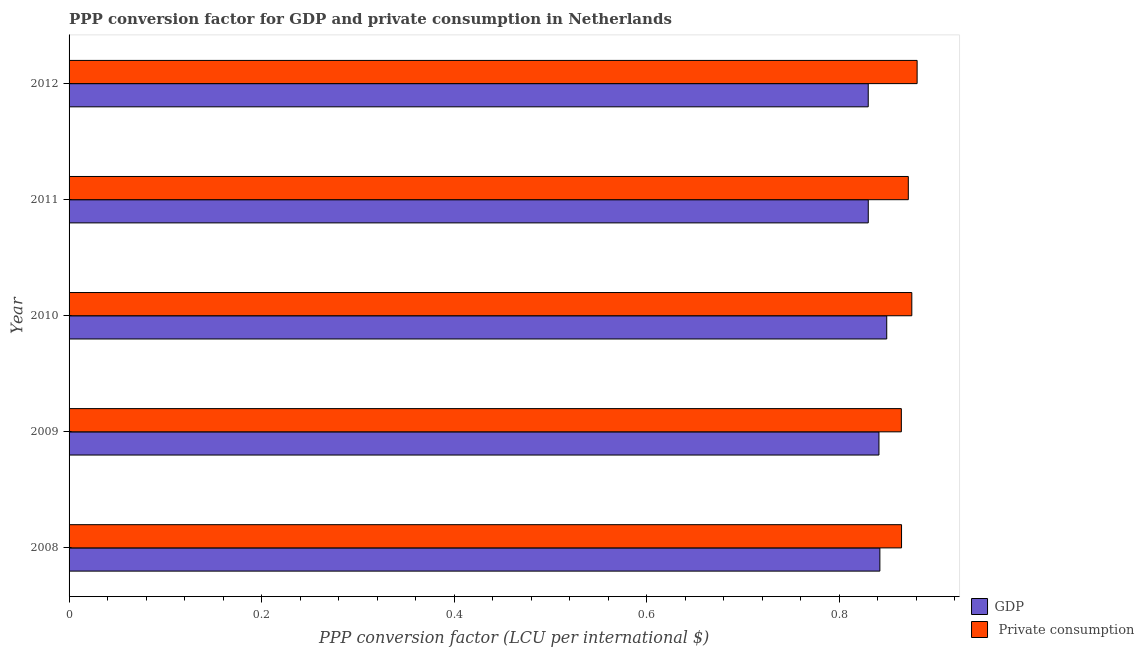Are the number of bars on each tick of the Y-axis equal?
Keep it short and to the point. Yes. How many bars are there on the 4th tick from the top?
Offer a very short reply. 2. How many bars are there on the 5th tick from the bottom?
Ensure brevity in your answer.  2. In how many cases, is the number of bars for a given year not equal to the number of legend labels?
Your answer should be compact. 0. What is the ppp conversion factor for gdp in 2008?
Offer a terse response. 0.84. Across all years, what is the maximum ppp conversion factor for private consumption?
Your response must be concise. 0.88. Across all years, what is the minimum ppp conversion factor for gdp?
Provide a succinct answer. 0.83. In which year was the ppp conversion factor for private consumption minimum?
Offer a very short reply. 2009. What is the total ppp conversion factor for private consumption in the graph?
Give a very brief answer. 4.36. What is the difference between the ppp conversion factor for private consumption in 2008 and that in 2009?
Keep it short and to the point. 0. What is the difference between the ppp conversion factor for gdp in 2012 and the ppp conversion factor for private consumption in 2008?
Make the answer very short. -0.03. What is the average ppp conversion factor for gdp per year?
Your answer should be very brief. 0.84. In the year 2009, what is the difference between the ppp conversion factor for private consumption and ppp conversion factor for gdp?
Offer a very short reply. 0.02. In how many years, is the ppp conversion factor for gdp greater than 0.32 LCU?
Your response must be concise. 5. What is the ratio of the ppp conversion factor for gdp in 2011 to that in 2012?
Provide a succinct answer. 1. What is the difference between the highest and the second highest ppp conversion factor for gdp?
Ensure brevity in your answer.  0.01. Is the sum of the ppp conversion factor for private consumption in 2009 and 2011 greater than the maximum ppp conversion factor for gdp across all years?
Give a very brief answer. Yes. What does the 1st bar from the top in 2009 represents?
Your answer should be compact.  Private consumption. What does the 1st bar from the bottom in 2010 represents?
Provide a short and direct response. GDP. How many bars are there?
Your answer should be compact. 10. Are the values on the major ticks of X-axis written in scientific E-notation?
Offer a terse response. No. Does the graph contain grids?
Offer a terse response. No. Where does the legend appear in the graph?
Your response must be concise. Bottom right. How are the legend labels stacked?
Offer a terse response. Vertical. What is the title of the graph?
Your response must be concise. PPP conversion factor for GDP and private consumption in Netherlands. What is the label or title of the X-axis?
Make the answer very short. PPP conversion factor (LCU per international $). What is the label or title of the Y-axis?
Offer a very short reply. Year. What is the PPP conversion factor (LCU per international $) of GDP in 2008?
Your answer should be compact. 0.84. What is the PPP conversion factor (LCU per international $) in  Private consumption in 2008?
Your response must be concise. 0.86. What is the PPP conversion factor (LCU per international $) of GDP in 2009?
Provide a succinct answer. 0.84. What is the PPP conversion factor (LCU per international $) of  Private consumption in 2009?
Make the answer very short. 0.86. What is the PPP conversion factor (LCU per international $) of GDP in 2010?
Offer a very short reply. 0.85. What is the PPP conversion factor (LCU per international $) of  Private consumption in 2010?
Give a very brief answer. 0.88. What is the PPP conversion factor (LCU per international $) in GDP in 2011?
Your answer should be compact. 0.83. What is the PPP conversion factor (LCU per international $) in  Private consumption in 2011?
Your answer should be compact. 0.87. What is the PPP conversion factor (LCU per international $) in GDP in 2012?
Provide a succinct answer. 0.83. What is the PPP conversion factor (LCU per international $) in  Private consumption in 2012?
Your answer should be very brief. 0.88. Across all years, what is the maximum PPP conversion factor (LCU per international $) in GDP?
Ensure brevity in your answer.  0.85. Across all years, what is the maximum PPP conversion factor (LCU per international $) in  Private consumption?
Offer a terse response. 0.88. Across all years, what is the minimum PPP conversion factor (LCU per international $) of GDP?
Your answer should be compact. 0.83. Across all years, what is the minimum PPP conversion factor (LCU per international $) in  Private consumption?
Your answer should be compact. 0.86. What is the total PPP conversion factor (LCU per international $) of GDP in the graph?
Your response must be concise. 4.19. What is the total PPP conversion factor (LCU per international $) of  Private consumption in the graph?
Ensure brevity in your answer.  4.36. What is the difference between the PPP conversion factor (LCU per international $) in GDP in 2008 and that in 2009?
Give a very brief answer. 0. What is the difference between the PPP conversion factor (LCU per international $) of GDP in 2008 and that in 2010?
Provide a succinct answer. -0.01. What is the difference between the PPP conversion factor (LCU per international $) of  Private consumption in 2008 and that in 2010?
Give a very brief answer. -0.01. What is the difference between the PPP conversion factor (LCU per international $) in GDP in 2008 and that in 2011?
Your answer should be compact. 0.01. What is the difference between the PPP conversion factor (LCU per international $) in  Private consumption in 2008 and that in 2011?
Ensure brevity in your answer.  -0.01. What is the difference between the PPP conversion factor (LCU per international $) in GDP in 2008 and that in 2012?
Your answer should be very brief. 0.01. What is the difference between the PPP conversion factor (LCU per international $) in  Private consumption in 2008 and that in 2012?
Make the answer very short. -0.02. What is the difference between the PPP conversion factor (LCU per international $) of GDP in 2009 and that in 2010?
Provide a short and direct response. -0.01. What is the difference between the PPP conversion factor (LCU per international $) of  Private consumption in 2009 and that in 2010?
Ensure brevity in your answer.  -0.01. What is the difference between the PPP conversion factor (LCU per international $) of GDP in 2009 and that in 2011?
Give a very brief answer. 0.01. What is the difference between the PPP conversion factor (LCU per international $) in  Private consumption in 2009 and that in 2011?
Your answer should be very brief. -0.01. What is the difference between the PPP conversion factor (LCU per international $) in GDP in 2009 and that in 2012?
Offer a terse response. 0.01. What is the difference between the PPP conversion factor (LCU per international $) of  Private consumption in 2009 and that in 2012?
Provide a succinct answer. -0.02. What is the difference between the PPP conversion factor (LCU per international $) in GDP in 2010 and that in 2011?
Make the answer very short. 0.02. What is the difference between the PPP conversion factor (LCU per international $) in  Private consumption in 2010 and that in 2011?
Give a very brief answer. 0. What is the difference between the PPP conversion factor (LCU per international $) of GDP in 2010 and that in 2012?
Offer a very short reply. 0.02. What is the difference between the PPP conversion factor (LCU per international $) of  Private consumption in 2010 and that in 2012?
Give a very brief answer. -0.01. What is the difference between the PPP conversion factor (LCU per international $) in GDP in 2011 and that in 2012?
Provide a short and direct response. 0. What is the difference between the PPP conversion factor (LCU per international $) in  Private consumption in 2011 and that in 2012?
Ensure brevity in your answer.  -0.01. What is the difference between the PPP conversion factor (LCU per international $) of GDP in 2008 and the PPP conversion factor (LCU per international $) of  Private consumption in 2009?
Provide a short and direct response. -0.02. What is the difference between the PPP conversion factor (LCU per international $) in GDP in 2008 and the PPP conversion factor (LCU per international $) in  Private consumption in 2010?
Your answer should be very brief. -0.03. What is the difference between the PPP conversion factor (LCU per international $) in GDP in 2008 and the PPP conversion factor (LCU per international $) in  Private consumption in 2011?
Your response must be concise. -0.03. What is the difference between the PPP conversion factor (LCU per international $) of GDP in 2008 and the PPP conversion factor (LCU per international $) of  Private consumption in 2012?
Your answer should be compact. -0.04. What is the difference between the PPP conversion factor (LCU per international $) in GDP in 2009 and the PPP conversion factor (LCU per international $) in  Private consumption in 2010?
Provide a short and direct response. -0.03. What is the difference between the PPP conversion factor (LCU per international $) in GDP in 2009 and the PPP conversion factor (LCU per international $) in  Private consumption in 2011?
Give a very brief answer. -0.03. What is the difference between the PPP conversion factor (LCU per international $) in GDP in 2009 and the PPP conversion factor (LCU per international $) in  Private consumption in 2012?
Offer a terse response. -0.04. What is the difference between the PPP conversion factor (LCU per international $) in GDP in 2010 and the PPP conversion factor (LCU per international $) in  Private consumption in 2011?
Offer a terse response. -0.02. What is the difference between the PPP conversion factor (LCU per international $) of GDP in 2010 and the PPP conversion factor (LCU per international $) of  Private consumption in 2012?
Your response must be concise. -0.03. What is the difference between the PPP conversion factor (LCU per international $) in GDP in 2011 and the PPP conversion factor (LCU per international $) in  Private consumption in 2012?
Your response must be concise. -0.05. What is the average PPP conversion factor (LCU per international $) of GDP per year?
Provide a succinct answer. 0.84. What is the average PPP conversion factor (LCU per international $) of  Private consumption per year?
Your answer should be compact. 0.87. In the year 2008, what is the difference between the PPP conversion factor (LCU per international $) of GDP and PPP conversion factor (LCU per international $) of  Private consumption?
Provide a succinct answer. -0.02. In the year 2009, what is the difference between the PPP conversion factor (LCU per international $) of GDP and PPP conversion factor (LCU per international $) of  Private consumption?
Provide a short and direct response. -0.02. In the year 2010, what is the difference between the PPP conversion factor (LCU per international $) of GDP and PPP conversion factor (LCU per international $) of  Private consumption?
Make the answer very short. -0.03. In the year 2011, what is the difference between the PPP conversion factor (LCU per international $) in GDP and PPP conversion factor (LCU per international $) in  Private consumption?
Provide a succinct answer. -0.04. In the year 2012, what is the difference between the PPP conversion factor (LCU per international $) of GDP and PPP conversion factor (LCU per international $) of  Private consumption?
Your answer should be compact. -0.05. What is the ratio of the PPP conversion factor (LCU per international $) in GDP in 2008 to that in 2009?
Ensure brevity in your answer.  1. What is the ratio of the PPP conversion factor (LCU per international $) of  Private consumption in 2008 to that in 2009?
Your response must be concise. 1. What is the ratio of the PPP conversion factor (LCU per international $) in GDP in 2008 to that in 2011?
Ensure brevity in your answer.  1.01. What is the ratio of the PPP conversion factor (LCU per international $) of  Private consumption in 2008 to that in 2011?
Offer a terse response. 0.99. What is the ratio of the PPP conversion factor (LCU per international $) of GDP in 2008 to that in 2012?
Make the answer very short. 1.01. What is the ratio of the PPP conversion factor (LCU per international $) of  Private consumption in 2008 to that in 2012?
Give a very brief answer. 0.98. What is the ratio of the PPP conversion factor (LCU per international $) in GDP in 2009 to that in 2010?
Offer a very short reply. 0.99. What is the ratio of the PPP conversion factor (LCU per international $) in  Private consumption in 2009 to that in 2010?
Provide a short and direct response. 0.99. What is the ratio of the PPP conversion factor (LCU per international $) in GDP in 2009 to that in 2011?
Give a very brief answer. 1.01. What is the ratio of the PPP conversion factor (LCU per international $) in  Private consumption in 2009 to that in 2011?
Keep it short and to the point. 0.99. What is the ratio of the PPP conversion factor (LCU per international $) of GDP in 2009 to that in 2012?
Provide a succinct answer. 1.01. What is the ratio of the PPP conversion factor (LCU per international $) of  Private consumption in 2009 to that in 2012?
Your answer should be compact. 0.98. What is the ratio of the PPP conversion factor (LCU per international $) of GDP in 2010 to that in 2011?
Offer a terse response. 1.02. What is the ratio of the PPP conversion factor (LCU per international $) in GDP in 2010 to that in 2012?
Offer a terse response. 1.02. What is the ratio of the PPP conversion factor (LCU per international $) of  Private consumption in 2010 to that in 2012?
Keep it short and to the point. 0.99. What is the ratio of the PPP conversion factor (LCU per international $) of  Private consumption in 2011 to that in 2012?
Provide a succinct answer. 0.99. What is the difference between the highest and the second highest PPP conversion factor (LCU per international $) of GDP?
Give a very brief answer. 0.01. What is the difference between the highest and the second highest PPP conversion factor (LCU per international $) of  Private consumption?
Ensure brevity in your answer.  0.01. What is the difference between the highest and the lowest PPP conversion factor (LCU per international $) of GDP?
Offer a terse response. 0.02. What is the difference between the highest and the lowest PPP conversion factor (LCU per international $) in  Private consumption?
Offer a very short reply. 0.02. 